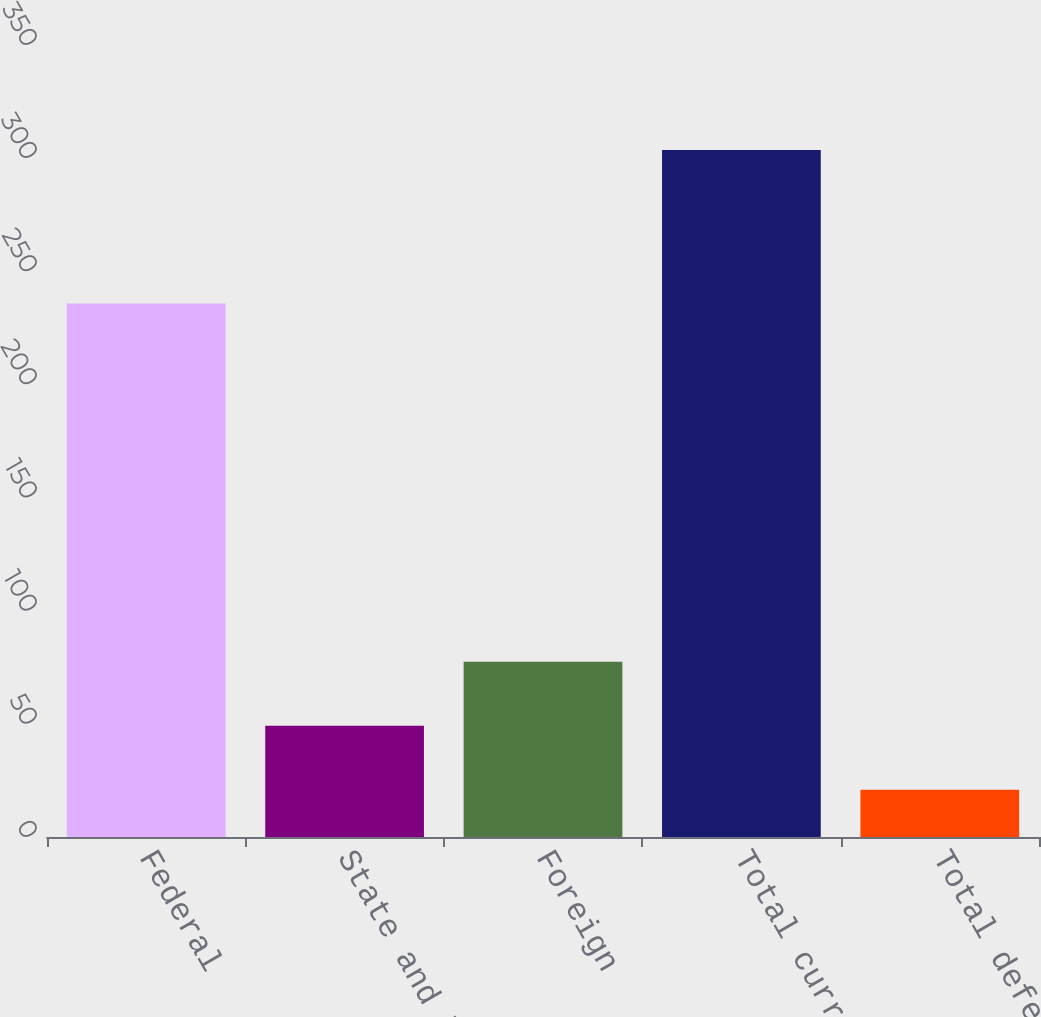Convert chart to OTSL. <chart><loc_0><loc_0><loc_500><loc_500><bar_chart><fcel>Federal<fcel>State and local<fcel>Foreign<fcel>Total current taxes<fcel>Total deferred taxes<nl><fcel>235.8<fcel>49.17<fcel>77.44<fcel>303.6<fcel>20.9<nl></chart> 